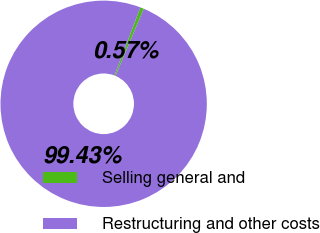<chart> <loc_0><loc_0><loc_500><loc_500><pie_chart><fcel>Selling general and<fcel>Restructuring and other costs<nl><fcel>0.57%<fcel>99.43%<nl></chart> 